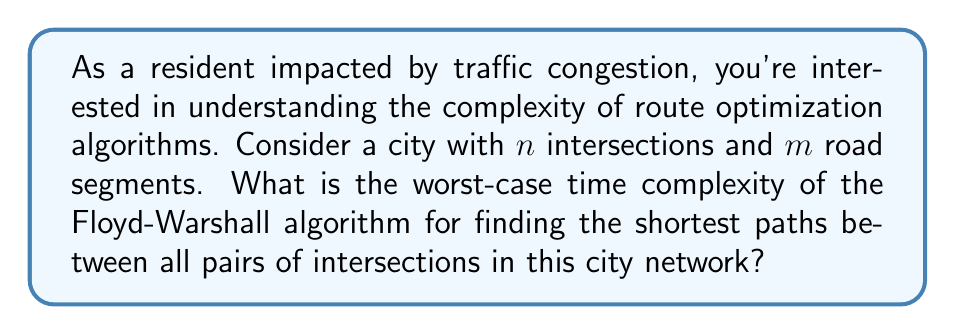Provide a solution to this math problem. To understand the complexity of the Floyd-Warshall algorithm in the context of traffic congestion, let's break down the problem:

1. City representation:
   - Intersections are represented as nodes (vertices) in a graph
   - Road segments are represented as edges in the graph
   - We have $n$ intersections and $m$ road segments

2. Floyd-Warshall algorithm:
   - This algorithm finds the shortest paths between all pairs of nodes in a weighted graph
   - It's particularly useful for traffic optimization as it can help identify the most efficient routes between any two points in the city

3. Algorithm structure:
   - The algorithm uses three nested loops, each iterating over all nodes
   - For each pair of nodes (i, j), it checks if going through an intermediate node k provides a shorter path

4. Complexity analysis:
   - Outer loop: Iterates $n$ times (for each potential intermediate node)
   - Middle loop: Iterates $n$ times (for each potential start node)
   - Inner loop: Iterates $n$ times (for each potential end node)
   - Total iterations: $n \times n \times n = n^3$

5. Time complexity:
   - Each iteration performs a constant number of operations
   - Therefore, the time complexity is proportional to the number of iterations
   - Worst-case time complexity: $O(n^3)$

6. Space complexity:
   - The algorithm typically uses an $n \times n$ matrix to store distances
   - Space complexity: $O(n^2)$

Note that this complexity is independent of the number of road segments $m$, as the algorithm considers all possible paths between intersections, not just the direct connections.

For large cities with many intersections, this cubic time complexity can become a significant bottleneck. However, for moderate-sized cities or specific neighborhoods, the Floyd-Warshall algorithm can provide valuable insights for traffic optimization and congestion reduction.
Answer: The worst-case time complexity of the Floyd-Warshall algorithm for finding the shortest paths between all pairs of intersections in a city network with $n$ intersections is $O(n^3)$. 